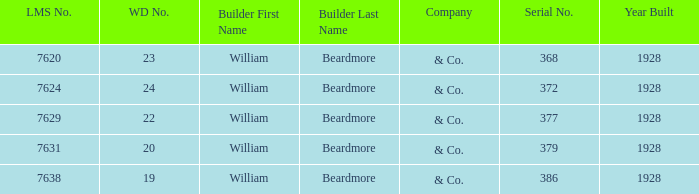Name the total number of serial number for 24 wd no 1.0. 